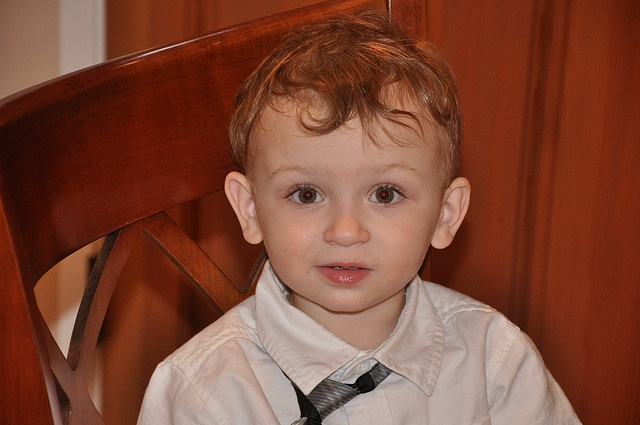Describe the objects in this image and their specific colors. I can see people in brown, darkgray, gray, maroon, and tan tones, chair in brown and maroon tones, and tie in brown, black, gray, and darkgray tones in this image. 